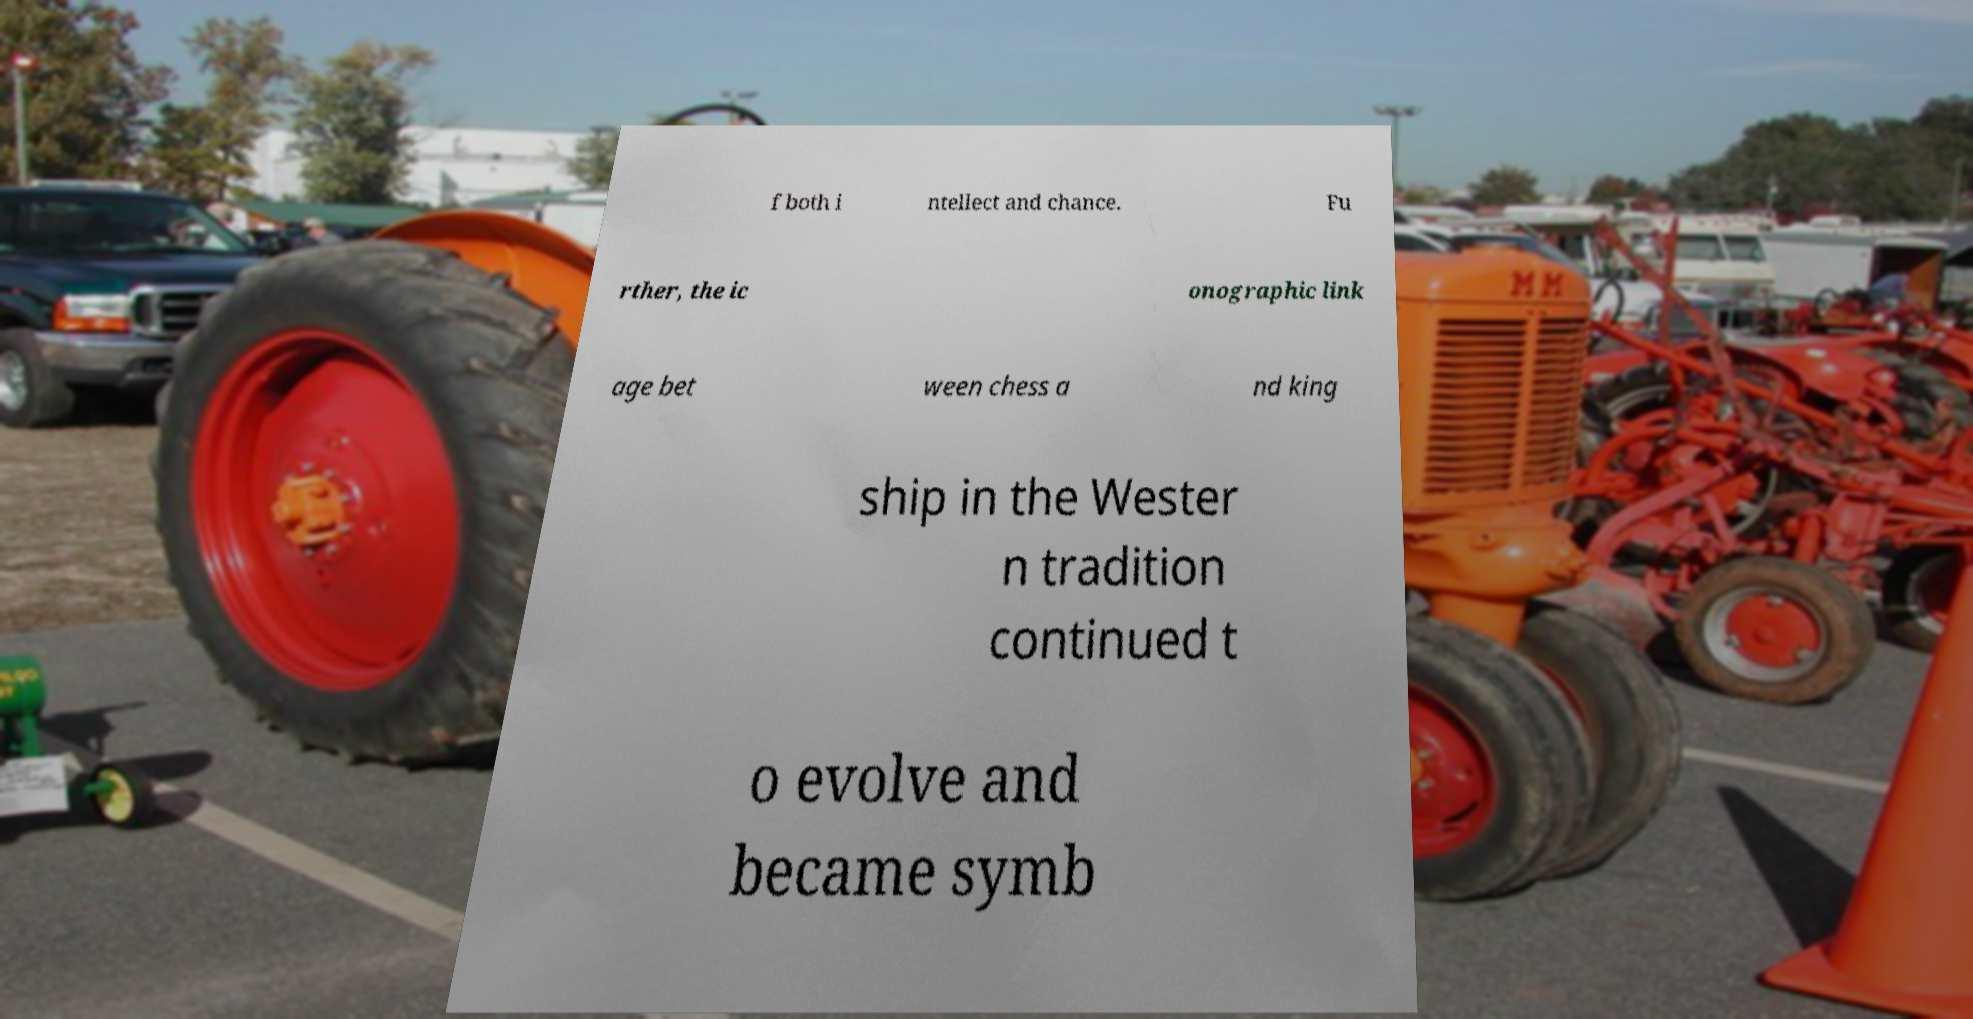Please read and relay the text visible in this image. What does it say? f both i ntellect and chance. Fu rther, the ic onographic link age bet ween chess a nd king ship in the Wester n tradition continued t o evolve and became symb 